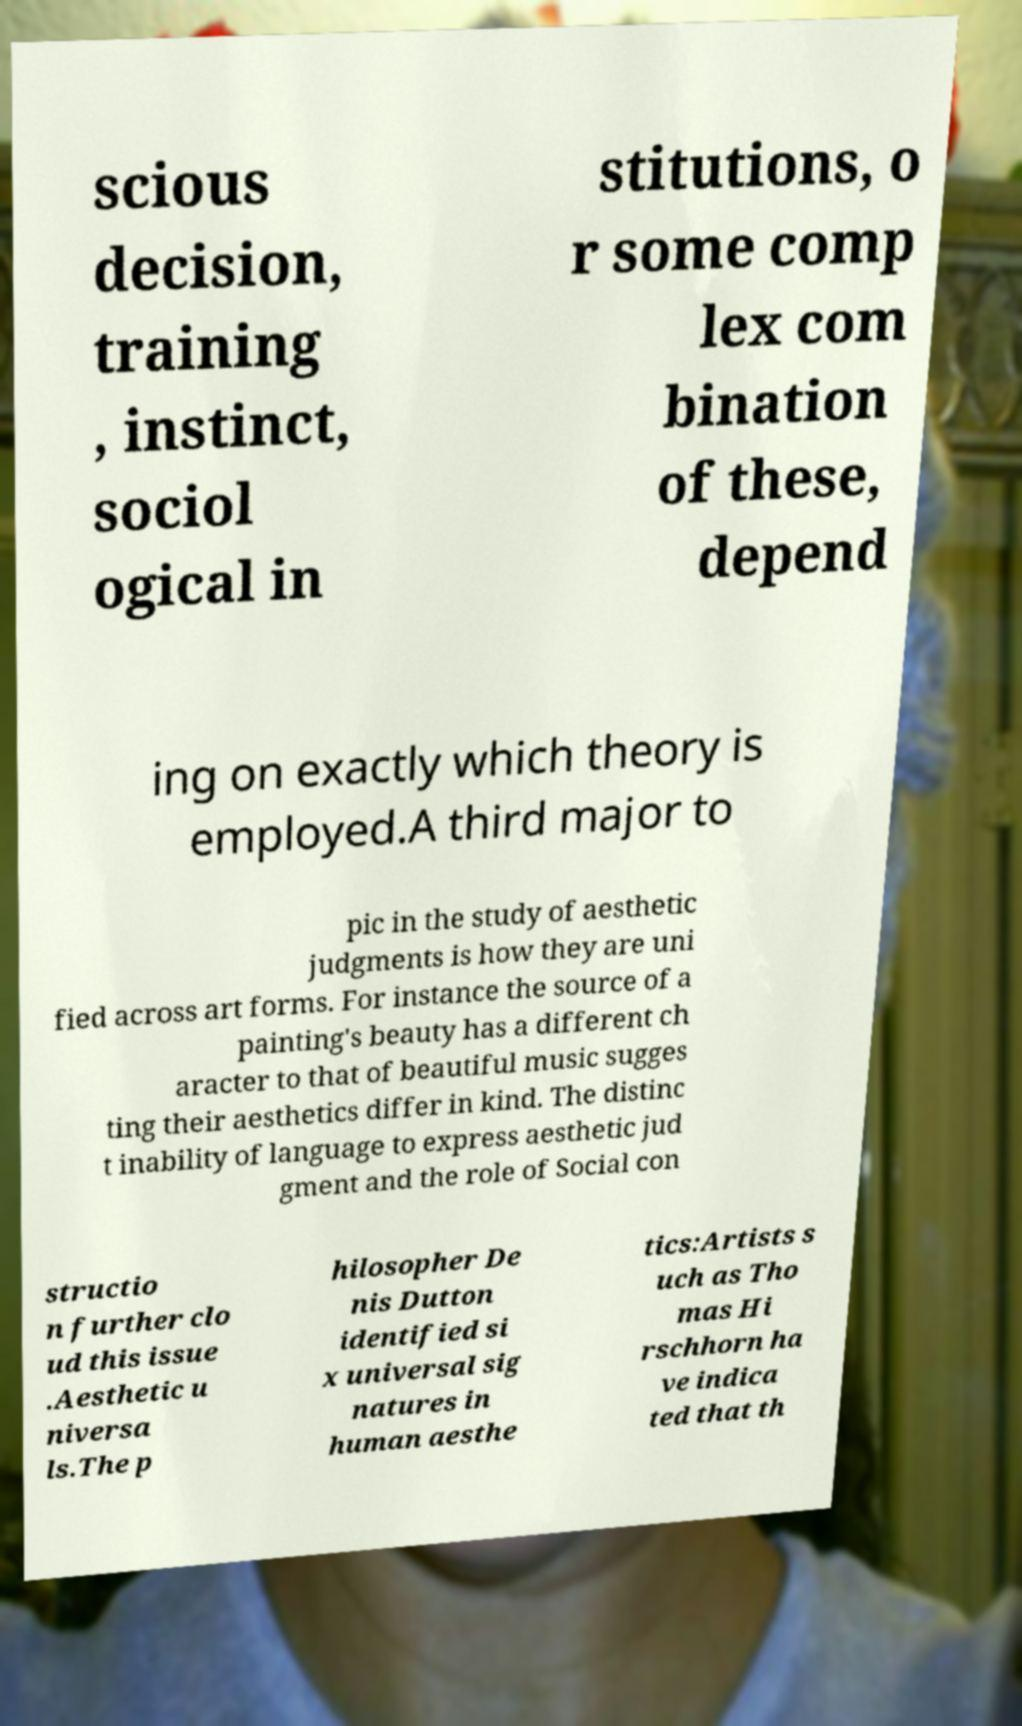Can you accurately transcribe the text from the provided image for me? scious decision, training , instinct, sociol ogical in stitutions, o r some comp lex com bination of these, depend ing on exactly which theory is employed.A third major to pic in the study of aesthetic judgments is how they are uni fied across art forms. For instance the source of a painting's beauty has a different ch aracter to that of beautiful music sugges ting their aesthetics differ in kind. The distinc t inability of language to express aesthetic jud gment and the role of Social con structio n further clo ud this issue .Aesthetic u niversa ls.The p hilosopher De nis Dutton identified si x universal sig natures in human aesthe tics:Artists s uch as Tho mas Hi rschhorn ha ve indica ted that th 